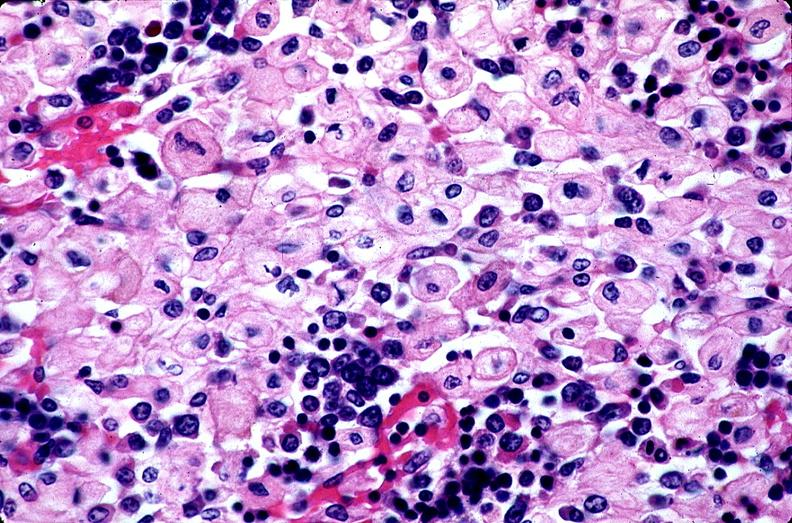what is present?
Answer the question using a single word or phrase. Hematologic 